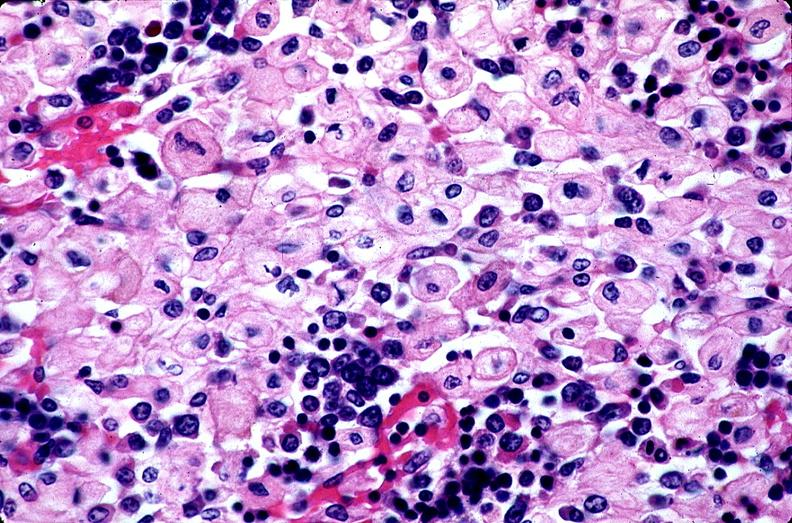what is present?
Answer the question using a single word or phrase. Hematologic 